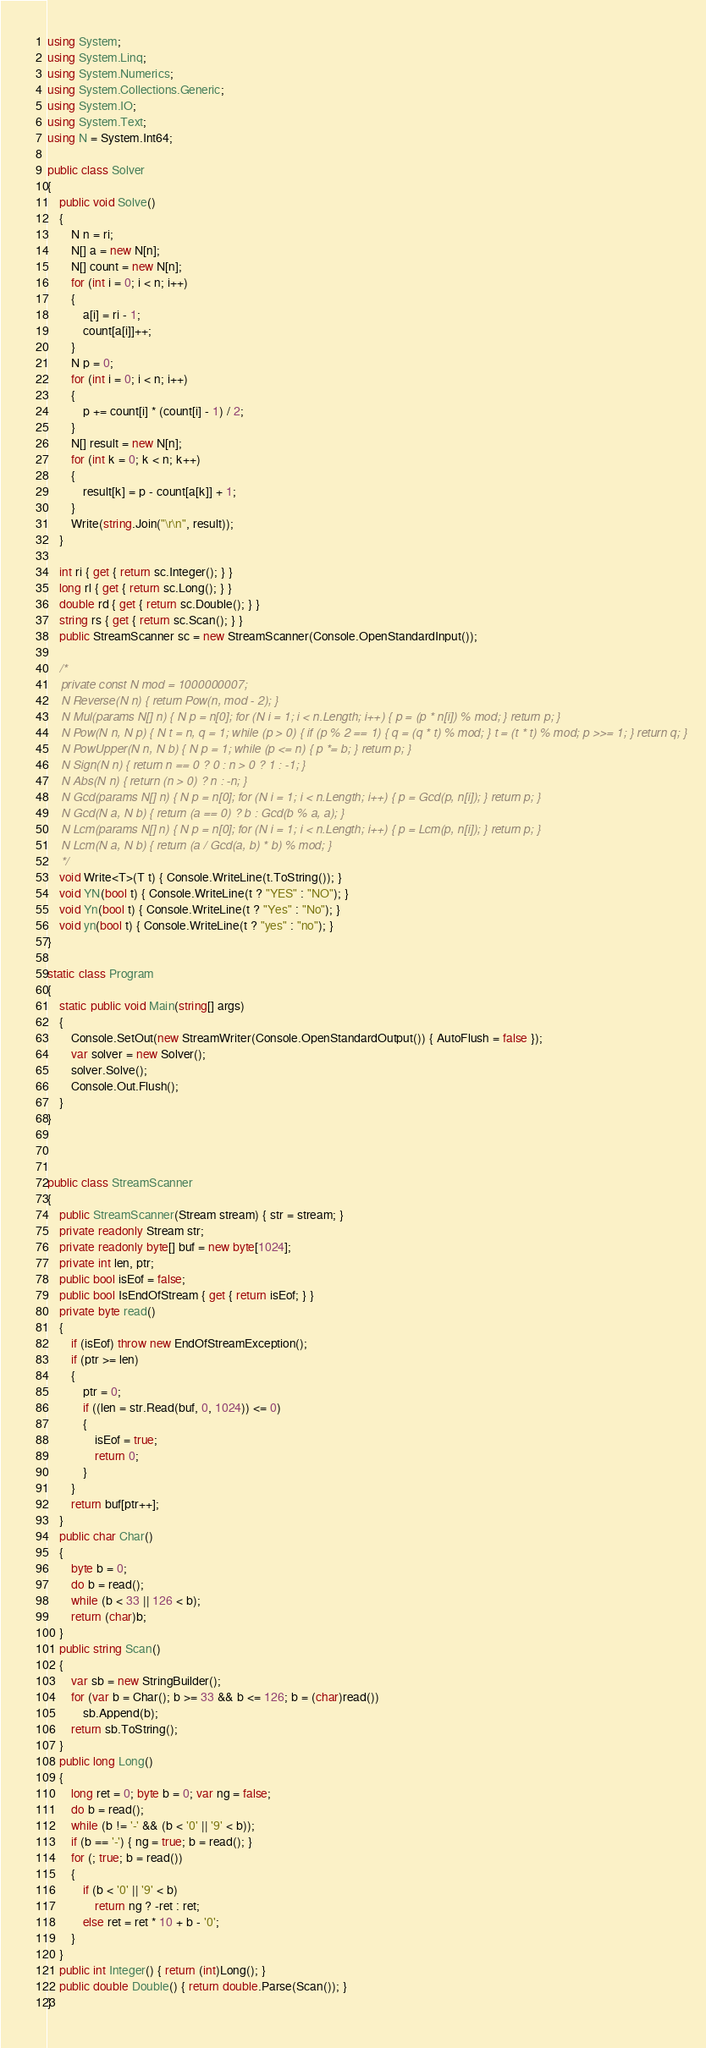<code> <loc_0><loc_0><loc_500><loc_500><_C#_>using System;
using System.Linq;
using System.Numerics;
using System.Collections.Generic;
using System.IO;
using System.Text;
using N = System.Int64;

public class Solver
{
    public void Solve()
    {
        N n = ri;
        N[] a = new N[n];
        N[] count = new N[n];
        for (int i = 0; i < n; i++)
        {
            a[i] = ri - 1;
            count[a[i]]++;
        }
        N p = 0;
        for (int i = 0; i < n; i++)
        {
            p += count[i] * (count[i] - 1) / 2;
        }
        N[] result = new N[n];
        for (int k = 0; k < n; k++)
        {
            result[k] = p - count[a[k]] + 1;
        }
        Write(string.Join("\r\n", result));
    }

    int ri { get { return sc.Integer(); } }
    long rl { get { return sc.Long(); } }
    double rd { get { return sc.Double(); } }
    string rs { get { return sc.Scan(); } }
    public StreamScanner sc = new StreamScanner(Console.OpenStandardInput());

    /*
    private const N mod = 1000000007;
    N Reverse(N n) { return Pow(n, mod - 2); }
    N Mul(params N[] n) { N p = n[0]; for (N i = 1; i < n.Length; i++) { p = (p * n[i]) % mod; } return p; }
    N Pow(N n, N p) { N t = n, q = 1; while (p > 0) { if (p % 2 == 1) { q = (q * t) % mod; } t = (t * t) % mod; p >>= 1; } return q; }
    N PowUpper(N n, N b) { N p = 1; while (p <= n) { p *= b; } return p; }
    N Sign(N n) { return n == 0 ? 0 : n > 0 ? 1 : -1; }
    N Abs(N n) { return (n > 0) ? n : -n; }
    N Gcd(params N[] n) { N p = n[0]; for (N i = 1; i < n.Length; i++) { p = Gcd(p, n[i]); } return p; }
    N Gcd(N a, N b) { return (a == 0) ? b : Gcd(b % a, a); }
    N Lcm(params N[] n) { N p = n[0]; for (N i = 1; i < n.Length; i++) { p = Lcm(p, n[i]); } return p; }
    N Lcm(N a, N b) { return (a / Gcd(a, b) * b) % mod; }
    */
    void Write<T>(T t) { Console.WriteLine(t.ToString()); }
    void YN(bool t) { Console.WriteLine(t ? "YES" : "NO"); }
    void Yn(bool t) { Console.WriteLine(t ? "Yes" : "No"); }
    void yn(bool t) { Console.WriteLine(t ? "yes" : "no"); }
}

static class Program
{
    static public void Main(string[] args)
    {
        Console.SetOut(new StreamWriter(Console.OpenStandardOutput()) { AutoFlush = false });
        var solver = new Solver();
        solver.Solve();
        Console.Out.Flush();
    }
}



public class StreamScanner
{
    public StreamScanner(Stream stream) { str = stream; }
    private readonly Stream str;
    private readonly byte[] buf = new byte[1024];
    private int len, ptr;
    public bool isEof = false;
    public bool IsEndOfStream { get { return isEof; } }
    private byte read()
    {
        if (isEof) throw new EndOfStreamException();
        if (ptr >= len)
        {
            ptr = 0;
            if ((len = str.Read(buf, 0, 1024)) <= 0)
            {
                isEof = true;
                return 0;
            }
        }
        return buf[ptr++];
    }
    public char Char()
    {
        byte b = 0;
        do b = read();
        while (b < 33 || 126 < b);
        return (char)b;
    }
    public string Scan()
    {
        var sb = new StringBuilder();
        for (var b = Char(); b >= 33 && b <= 126; b = (char)read())
            sb.Append(b);
        return sb.ToString();
    }
    public long Long()
    {
        long ret = 0; byte b = 0; var ng = false;
        do b = read();
        while (b != '-' && (b < '0' || '9' < b));
        if (b == '-') { ng = true; b = read(); }
        for (; true; b = read())
        {
            if (b < '0' || '9' < b)
                return ng ? -ret : ret;
            else ret = ret * 10 + b - '0';
        }
    }
    public int Integer() { return (int)Long(); }
    public double Double() { return double.Parse(Scan()); }
}
</code> 